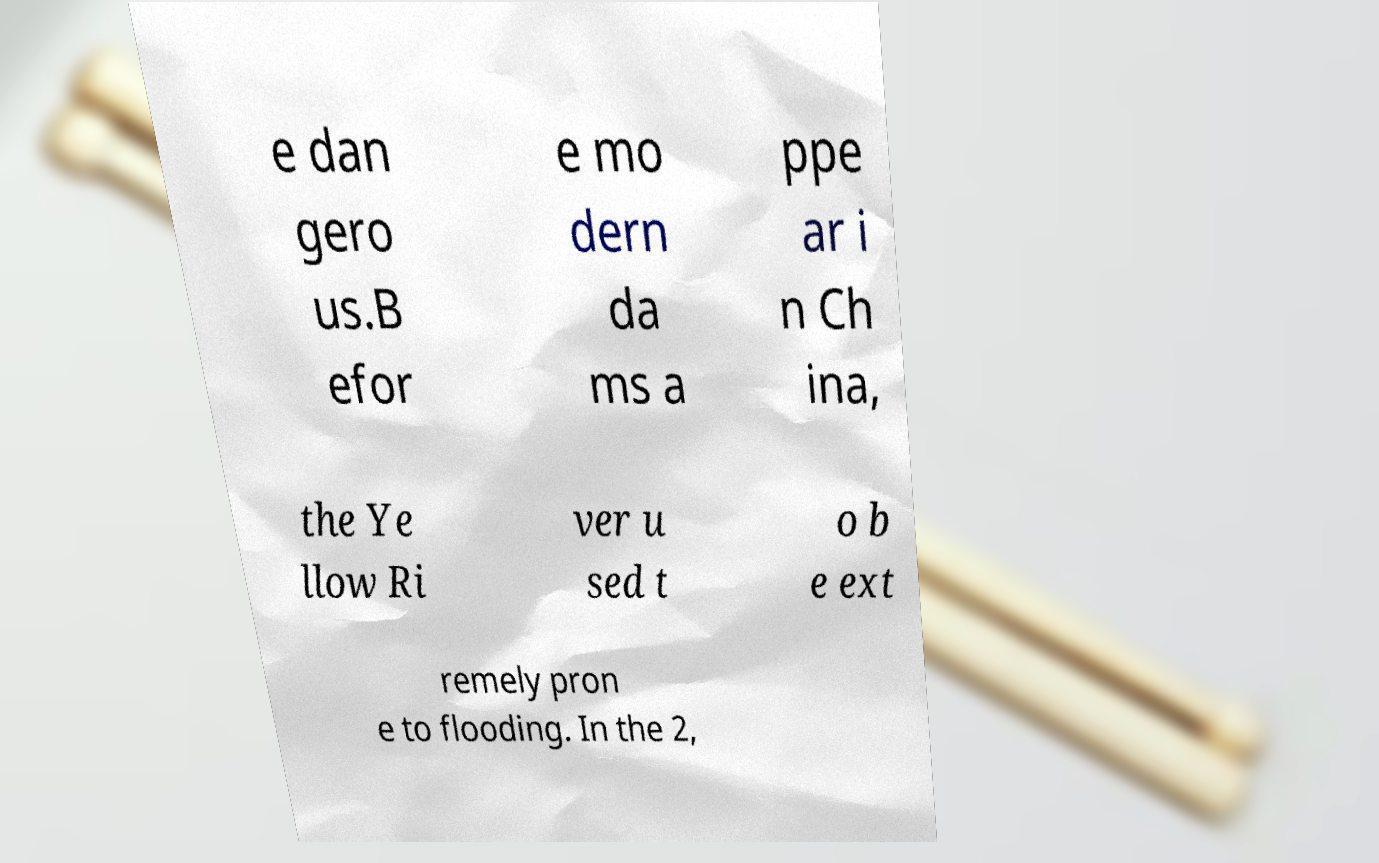Could you extract and type out the text from this image? e dan gero us.B efor e mo dern da ms a ppe ar i n Ch ina, the Ye llow Ri ver u sed t o b e ext remely pron e to flooding. In the 2, 